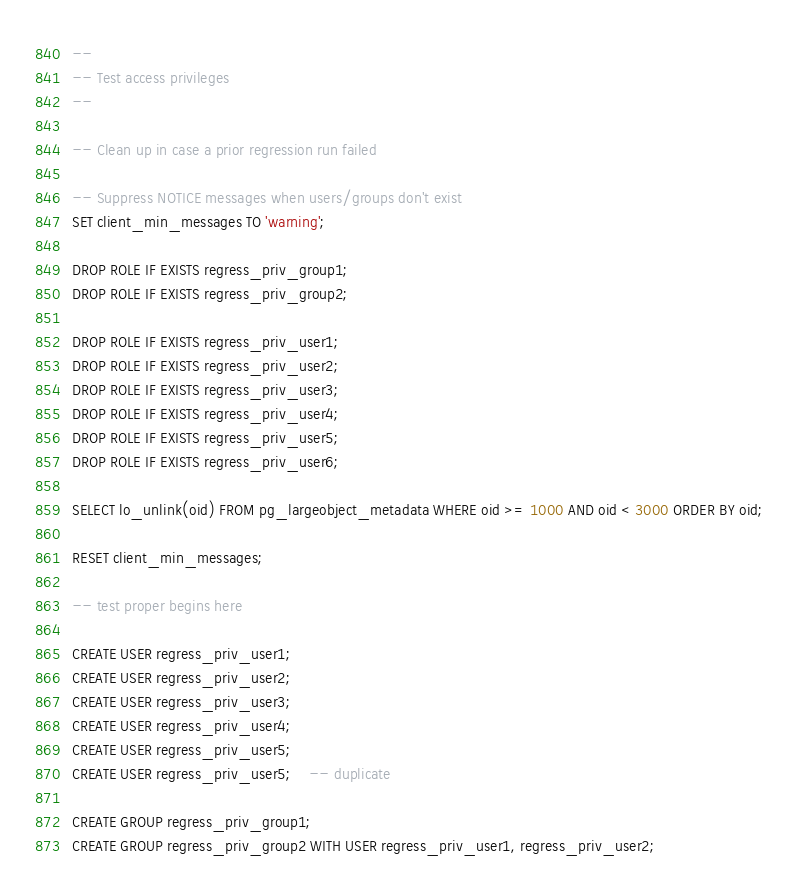Convert code to text. <code><loc_0><loc_0><loc_500><loc_500><_SQL_>--
-- Test access privileges
--

-- Clean up in case a prior regression run failed

-- Suppress NOTICE messages when users/groups don't exist
SET client_min_messages TO 'warning';

DROP ROLE IF EXISTS regress_priv_group1;
DROP ROLE IF EXISTS regress_priv_group2;

DROP ROLE IF EXISTS regress_priv_user1;
DROP ROLE IF EXISTS regress_priv_user2;
DROP ROLE IF EXISTS regress_priv_user3;
DROP ROLE IF EXISTS regress_priv_user4;
DROP ROLE IF EXISTS regress_priv_user5;
DROP ROLE IF EXISTS regress_priv_user6;

SELECT lo_unlink(oid) FROM pg_largeobject_metadata WHERE oid >= 1000 AND oid < 3000 ORDER BY oid;

RESET client_min_messages;

-- test proper begins here

CREATE USER regress_priv_user1;
CREATE USER regress_priv_user2;
CREATE USER regress_priv_user3;
CREATE USER regress_priv_user4;
CREATE USER regress_priv_user5;
CREATE USER regress_priv_user5;	-- duplicate

CREATE GROUP regress_priv_group1;
CREATE GROUP regress_priv_group2 WITH USER regress_priv_user1, regress_priv_user2;
</code> 